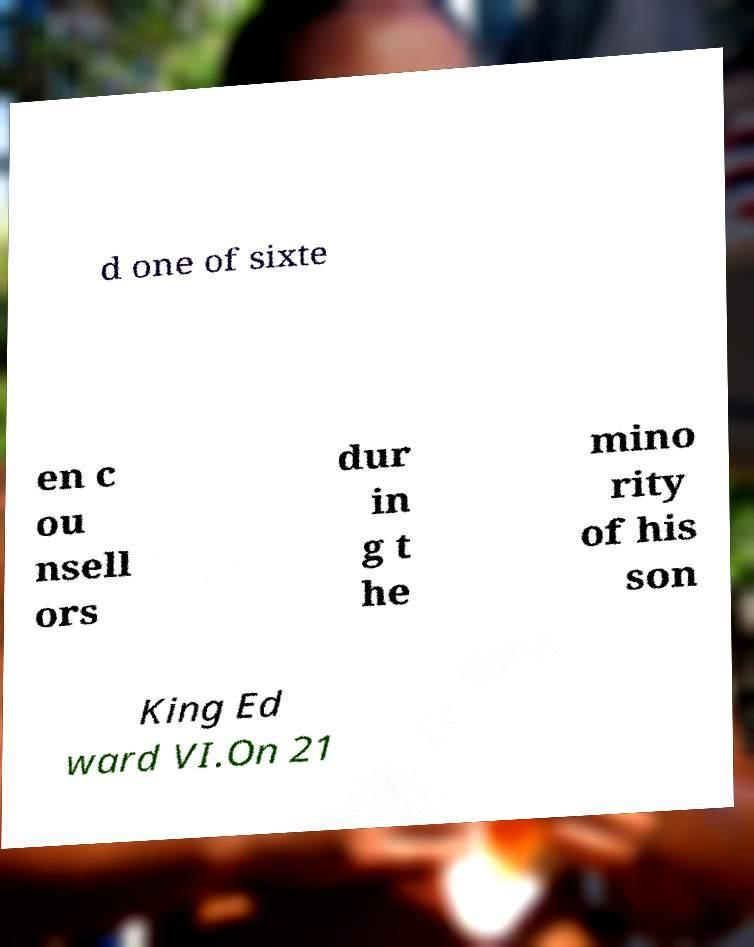Please read and relay the text visible in this image. What does it say? d one of sixte en c ou nsell ors dur in g t he mino rity of his son King Ed ward VI.On 21 